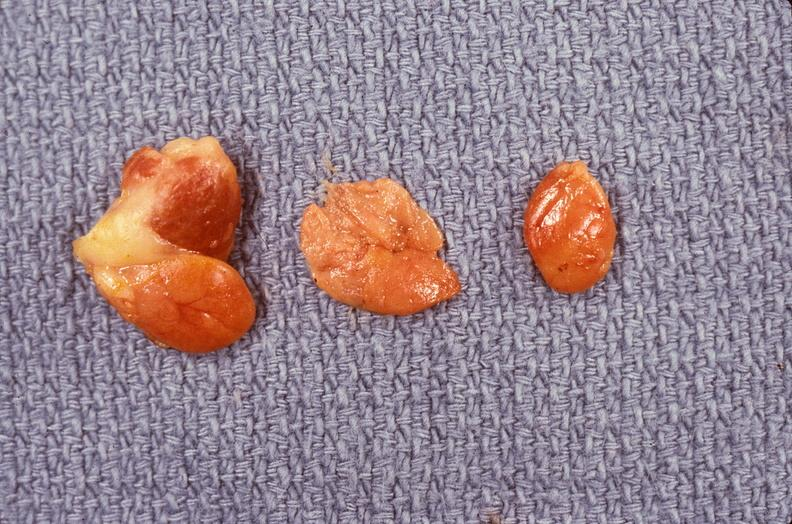where does this belong to?
Answer the question using a single word or phrase. Endocrine system 